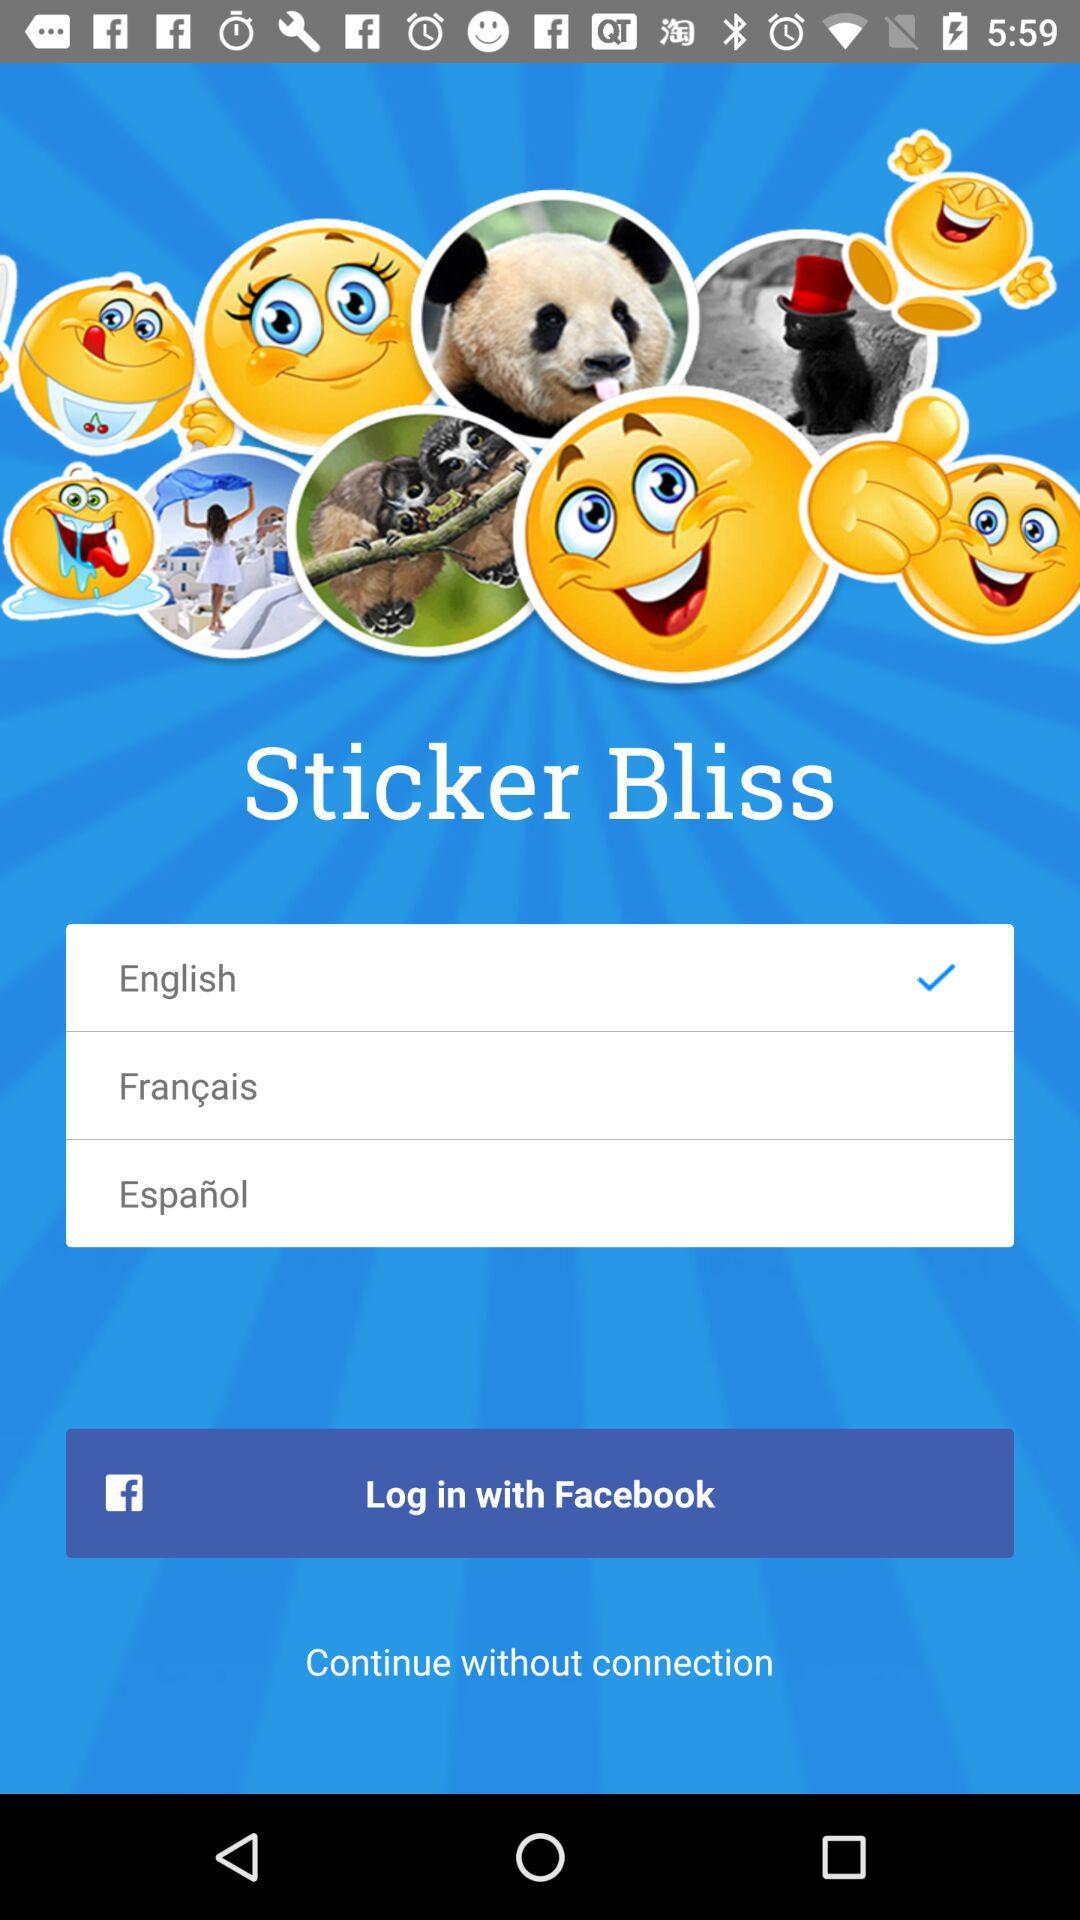Which language is selected? The selected language is English. 